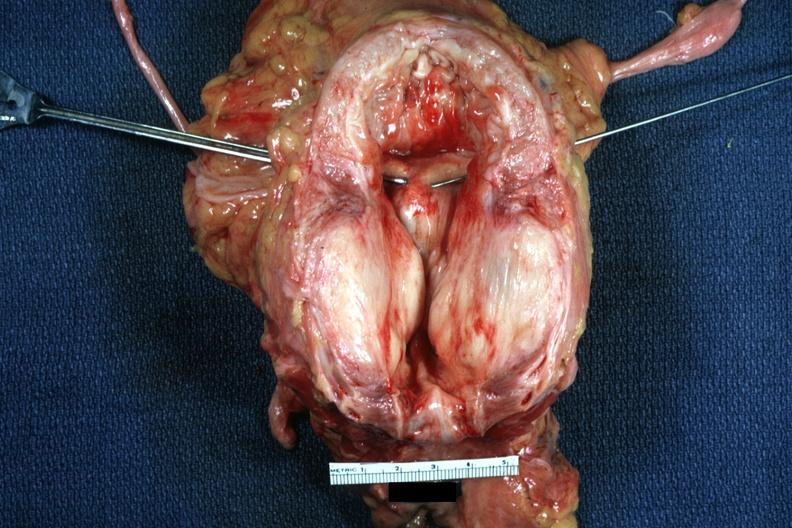what hypertrophied bladder?
Answer the question using a single word or phrase. Large gland 